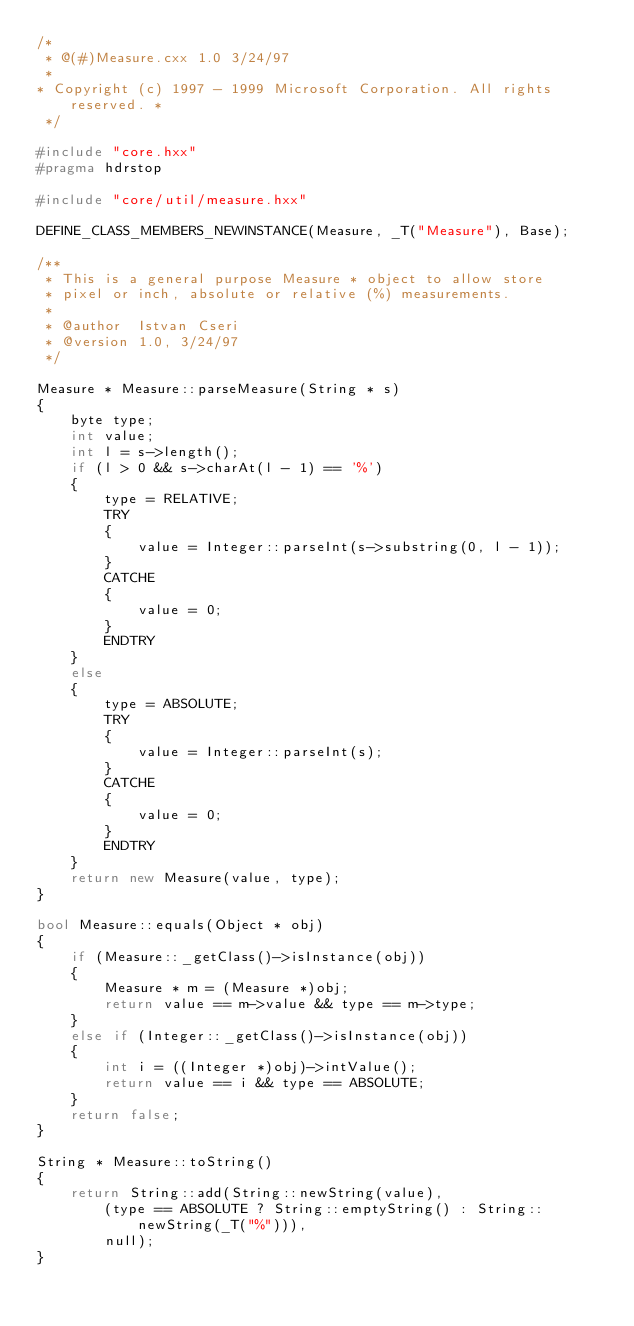Convert code to text. <code><loc_0><loc_0><loc_500><loc_500><_C++_>/*
 * @(#)Measure.cxx 1.0 3/24/97
 * 
* Copyright (c) 1997 - 1999 Microsoft Corporation. All rights reserved. * 
 */
 
#include "core.hxx"
#pragma hdrstop

#include "core/util/measure.hxx"

DEFINE_CLASS_MEMBERS_NEWINSTANCE(Measure, _T("Measure"), Base);

/**
 * This is a general purpose Measure * object to allow store
 * pixel or inch, absolute or relative (%) measurements.
 *
 * @author  Istvan Cseri
 * @version 1.0, 3/24/97
 */

Measure * Measure::parseMeasure(String * s)
{
    byte type;
    int value;
    int l = s->length();
    if (l > 0 && s->charAt(l - 1) == '%')
    {
        type = RELATIVE;
        TRY
        {
            value = Integer::parseInt(s->substring(0, l - 1));           
        }
        CATCHE
        {
            value = 0;
        }
        ENDTRY
    }
    else
    {
        type = ABSOLUTE;
        TRY
        {
            value = Integer::parseInt(s);           
        }
        CATCHE
        {
            value = 0;
        }
        ENDTRY
    }
    return new Measure(value, type);
}

bool Measure::equals(Object * obj)
{
    if (Measure::_getClass()->isInstance(obj))
    {
        Measure * m = (Measure *)obj;
        return value == m->value && type == m->type;
    }
    else if (Integer::_getClass()->isInstance(obj))
    {
        int i = ((Integer *)obj)->intValue();
        return value == i && type == ABSOLUTE;
    }
    return false;
}

String * Measure::toString()
{
    return String::add(String::newString(value),
        (type == ABSOLUTE ? String::emptyString() : String::newString(_T("%"))), 
        null);
}

</code> 